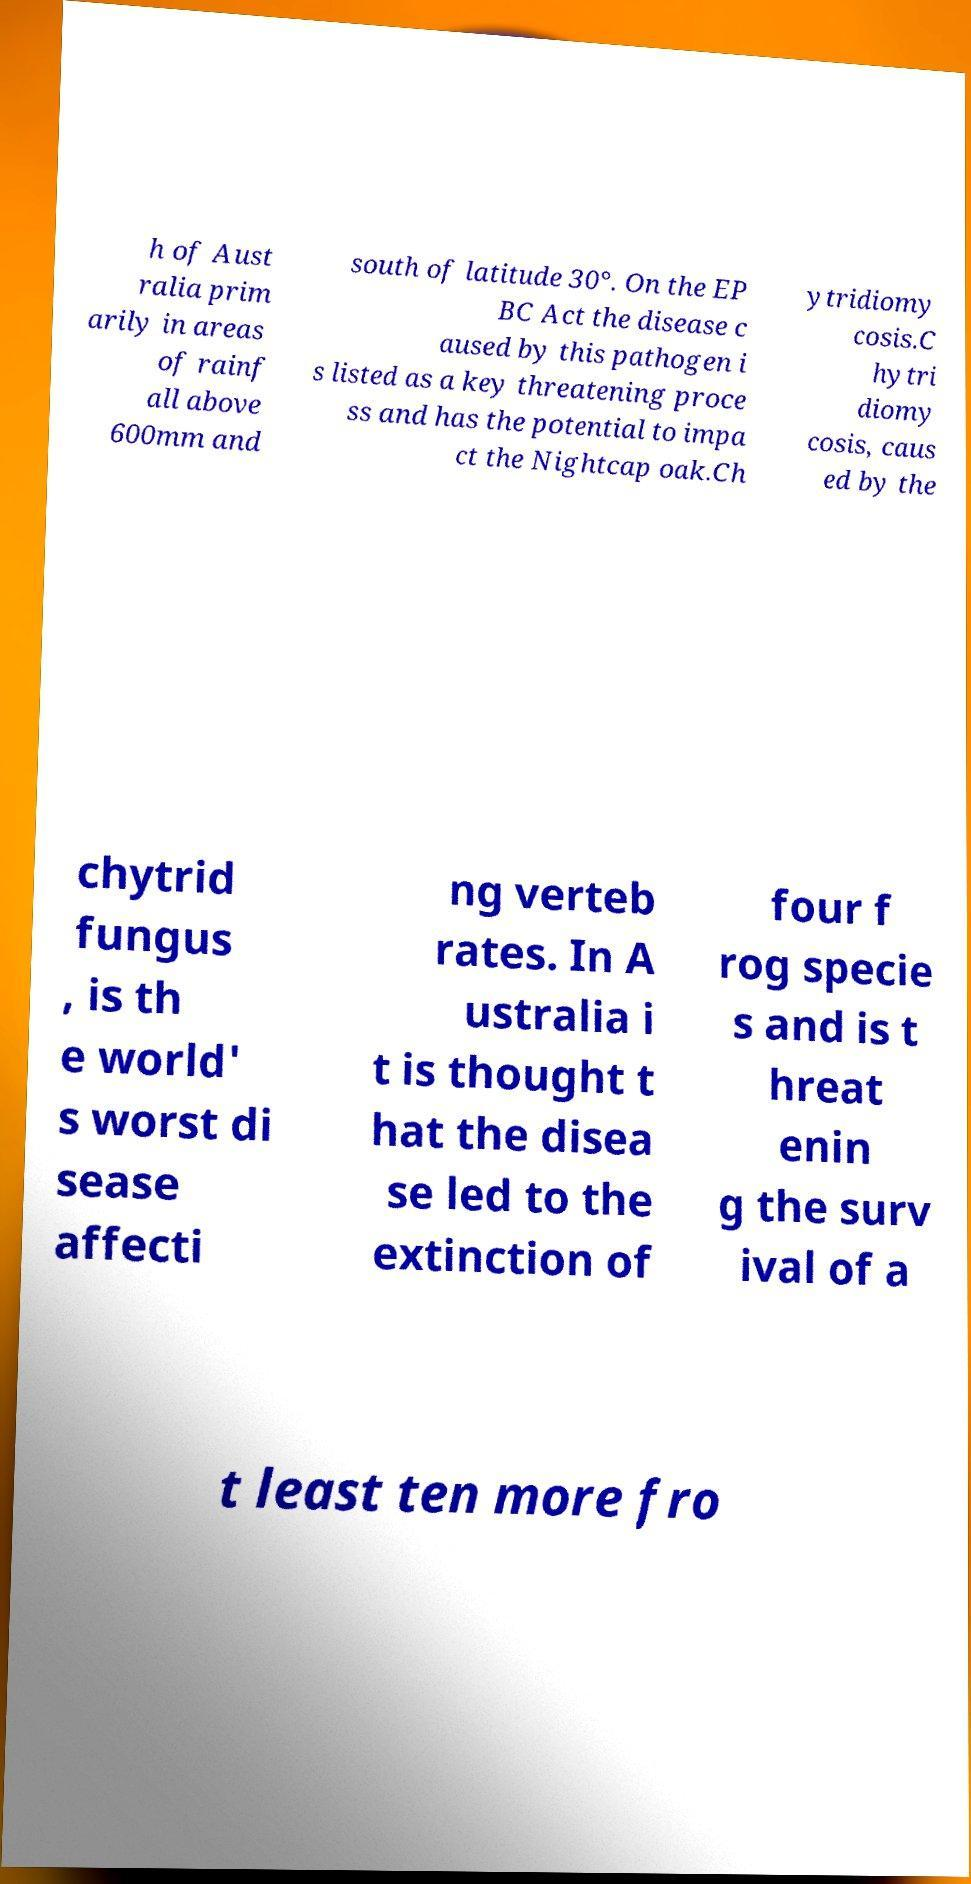What messages or text are displayed in this image? I need them in a readable, typed format. h of Aust ralia prim arily in areas of rainf all above 600mm and south of latitude 30°. On the EP BC Act the disease c aused by this pathogen i s listed as a key threatening proce ss and has the potential to impa ct the Nightcap oak.Ch ytridiomy cosis.C hytri diomy cosis, caus ed by the chytrid fungus , is th e world' s worst di sease affecti ng verteb rates. In A ustralia i t is thought t hat the disea se led to the extinction of four f rog specie s and is t hreat enin g the surv ival of a t least ten more fro 